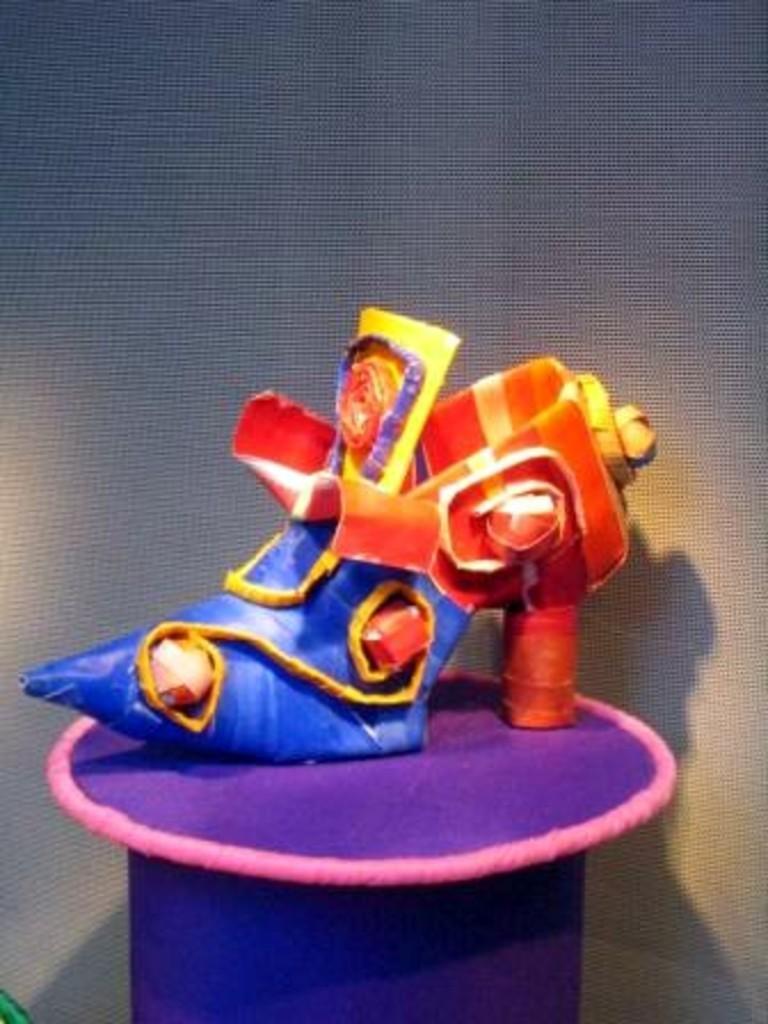In one or two sentences, can you explain what this image depicts? In this image I can see the shoe which is in purple. red, yellow and blue color. It is on the purple and pink color surface. And there is an ash color background. 